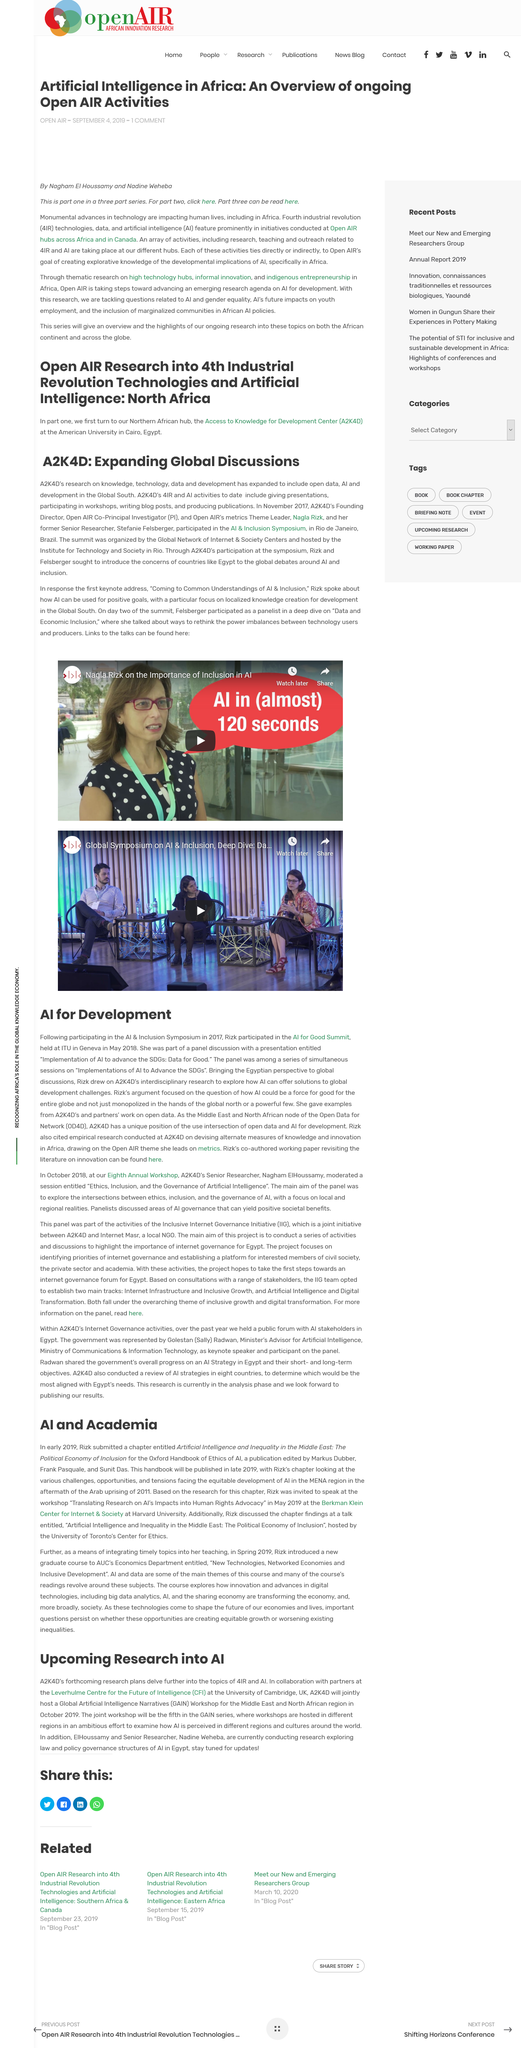Point out several critical features in this image. The AI & Inclusion Symposium took place in November 2017. Rizk was speaking at the Berkman Klein Center for Internet and Society. Rizk submitted the chapter in early 2019. The AI & Inclusion Symposium was held in Rio de Janeiro, Brazil. The Global Artificial Intelligence Narratives Workshop for the Middle East and North African region took place in October 2019. 